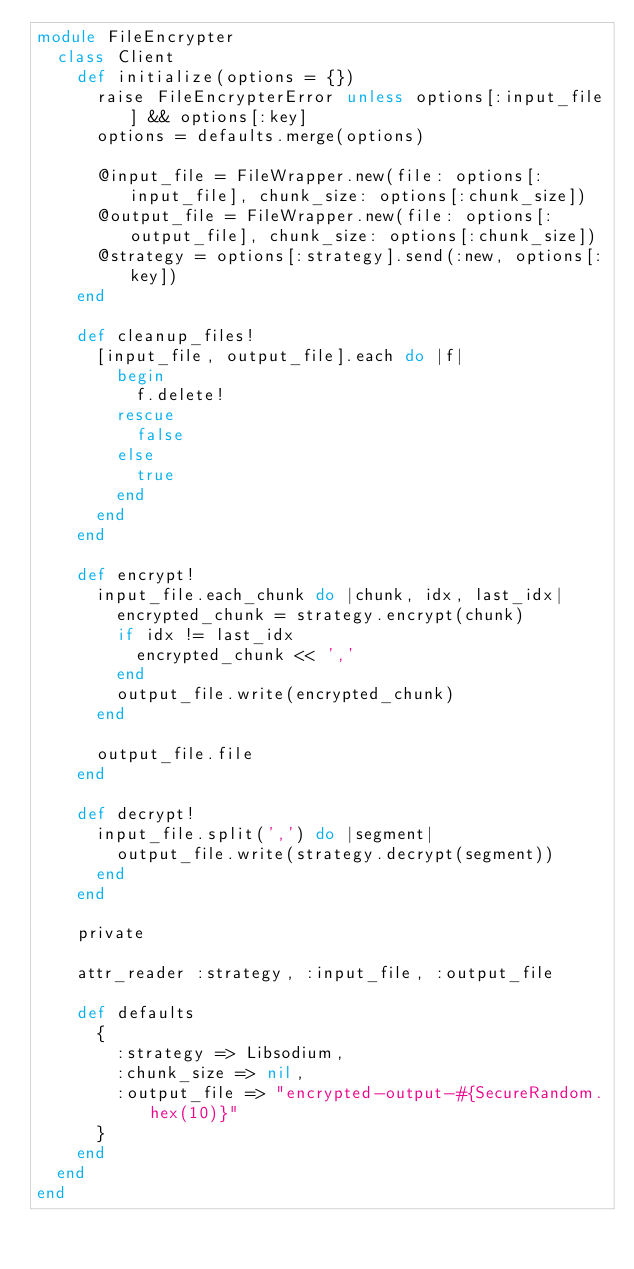Convert code to text. <code><loc_0><loc_0><loc_500><loc_500><_Ruby_>module FileEncrypter
  class Client 
    def initialize(options = {})
      raise FileEncrypterError unless options[:input_file] && options[:key] 
      options = defaults.merge(options)

      @input_file = FileWrapper.new(file: options[:input_file], chunk_size: options[:chunk_size])
      @output_file = FileWrapper.new(file: options[:output_file], chunk_size: options[:chunk_size])
      @strategy = options[:strategy].send(:new, options[:key]) 
    end
    
    def cleanup_files!
      [input_file, output_file].each do |f|  
        begin 
          f.delete! 
        rescue
          false
        else
          true
        end
      end 
    end

    def encrypt!
      input_file.each_chunk do |chunk, idx, last_idx|
        encrypted_chunk = strategy.encrypt(chunk)    
        if idx != last_idx 
          encrypted_chunk << ',' 
        end
        output_file.write(encrypted_chunk)
      end

      output_file.file
    end

    def decrypt!
      input_file.split(',') do |segment|
        output_file.write(strategy.decrypt(segment))
      end
    end

    private

    attr_reader :strategy, :input_file, :output_file
    
    def defaults
      {
        :strategy => Libsodium,
        :chunk_size => nil,
        :output_file => "encrypted-output-#{SecureRandom.hex(10)}"
      }    
    end
  end
end
</code> 